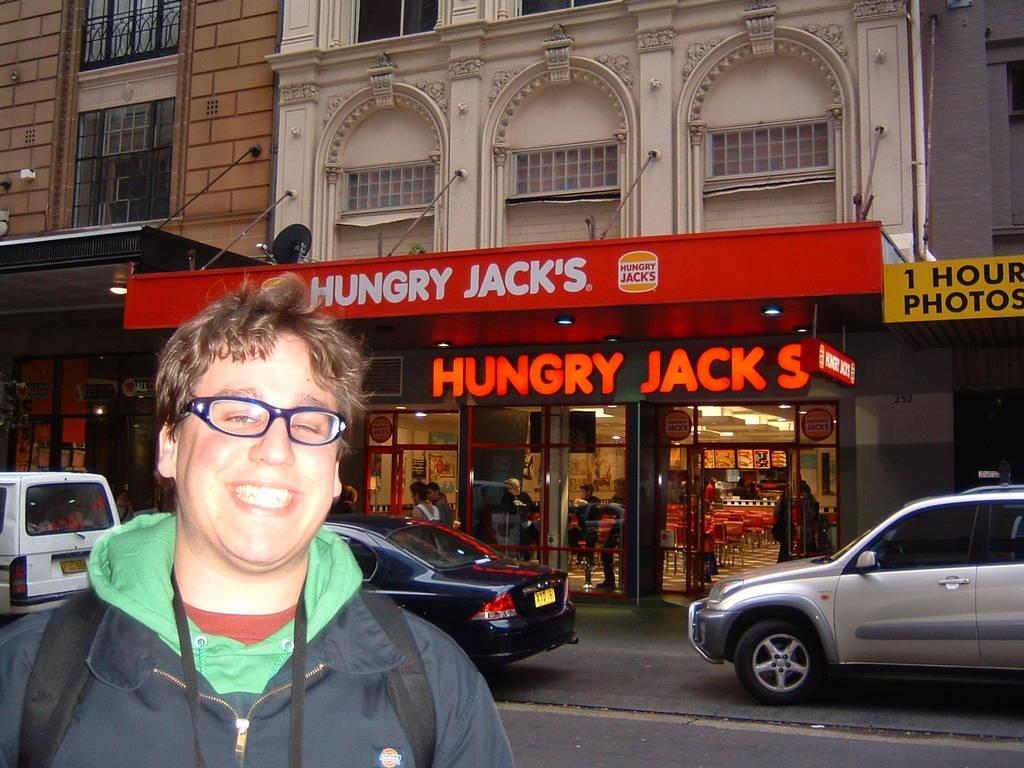How would you summarize this image in a sentence or two? In the bottom left there is a person standing wearing jacket, bag and glasses, in the background there are cars on a road and there is building for that building there are windows and boards, on that boards there is some text and there are glass doors. 